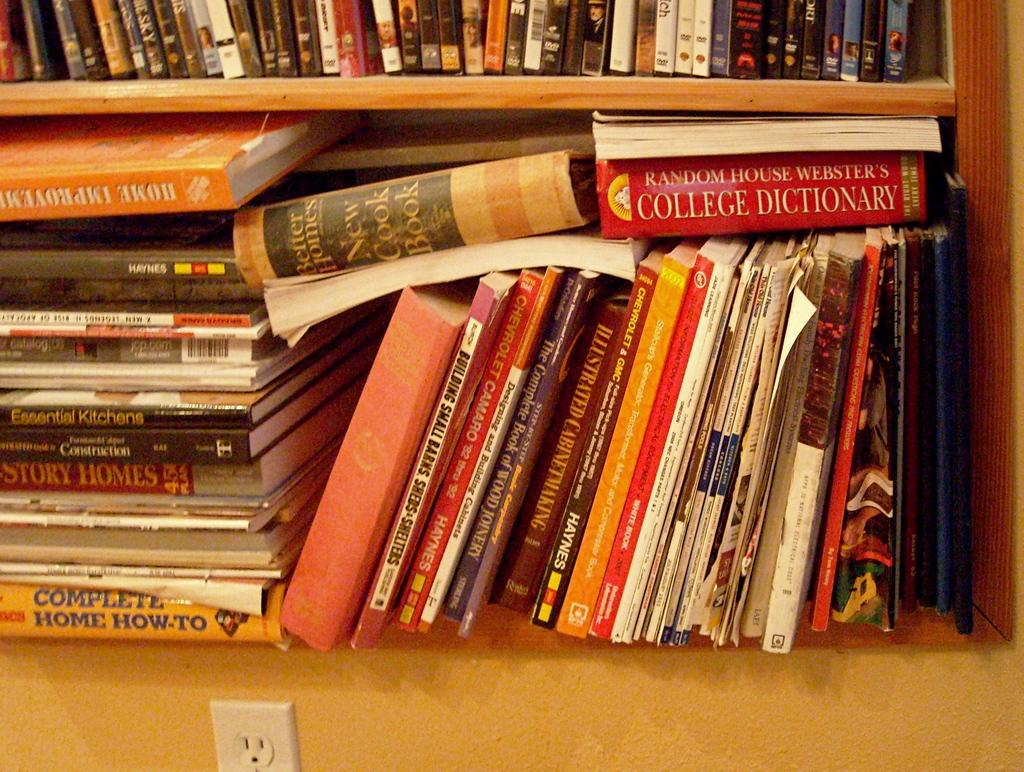Provide a one-sentence caption for the provided image. A collection of books, including a cook book and a dictionary. 